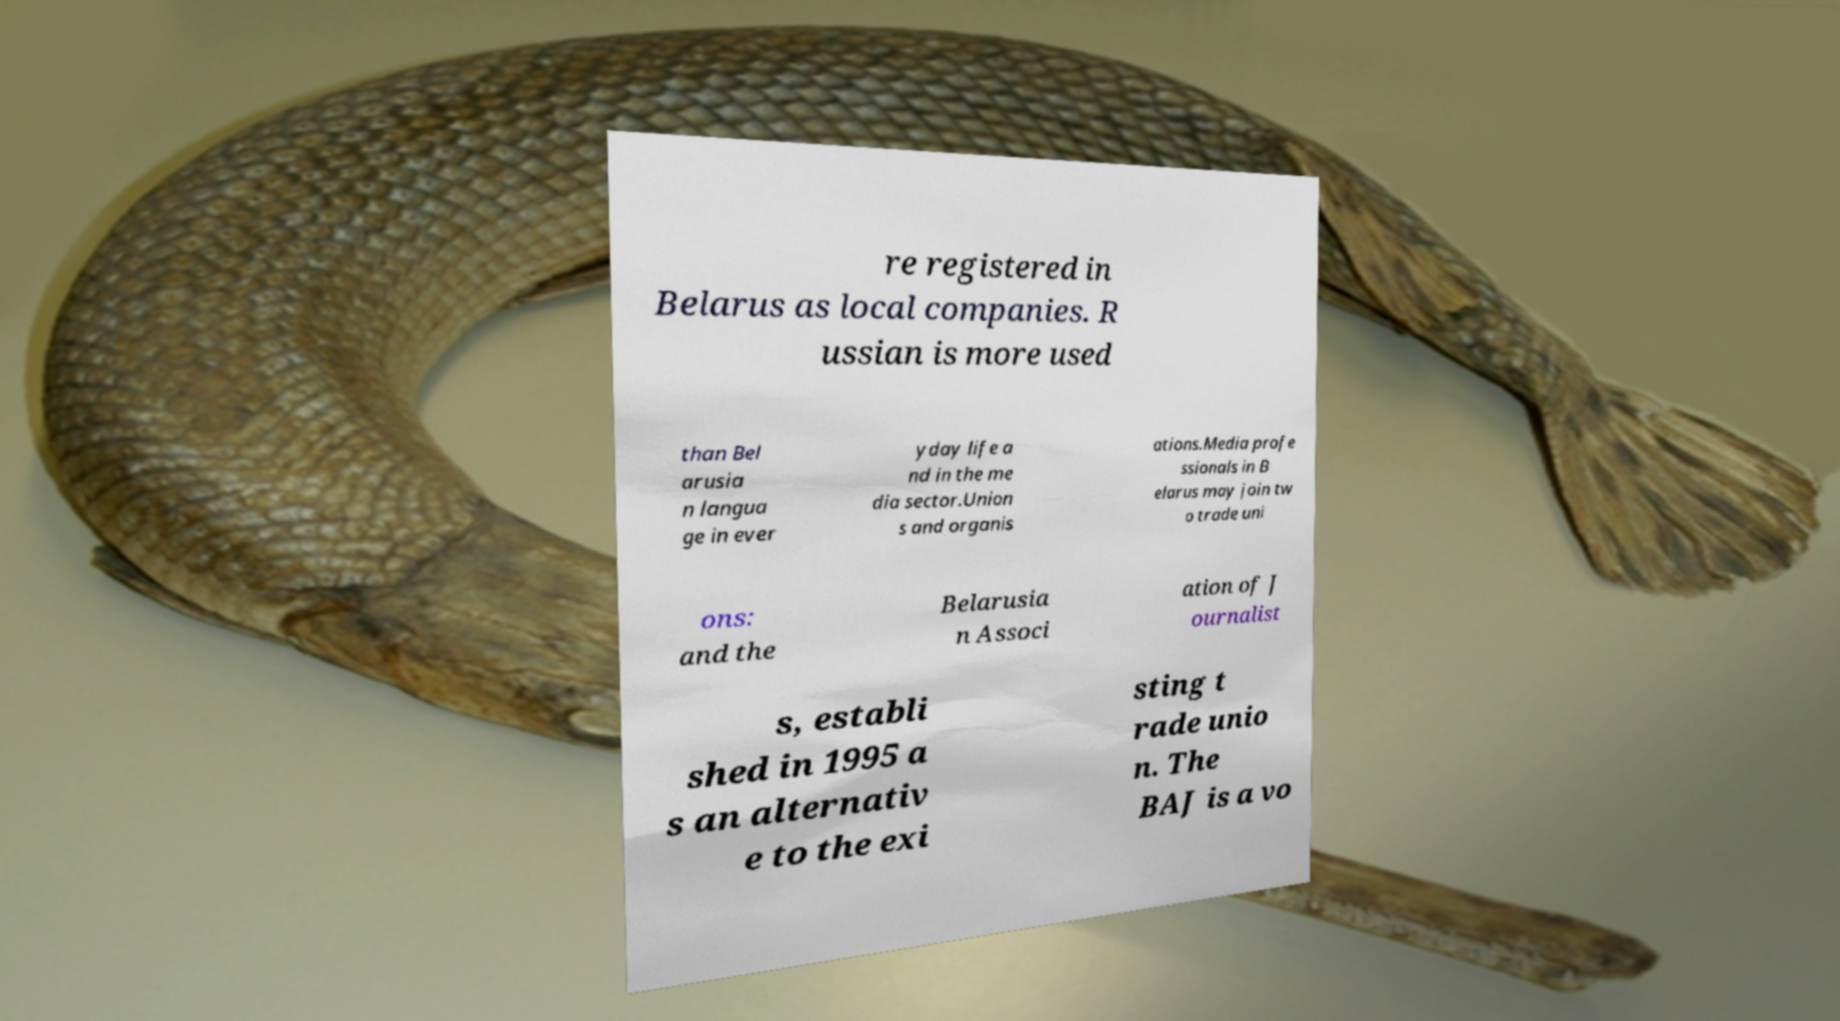Please identify and transcribe the text found in this image. re registered in Belarus as local companies. R ussian is more used than Bel arusia n langua ge in ever yday life a nd in the me dia sector.Union s and organis ations.Media profe ssionals in B elarus may join tw o trade uni ons: and the Belarusia n Associ ation of J ournalist s, establi shed in 1995 a s an alternativ e to the exi sting t rade unio n. The BAJ is a vo 